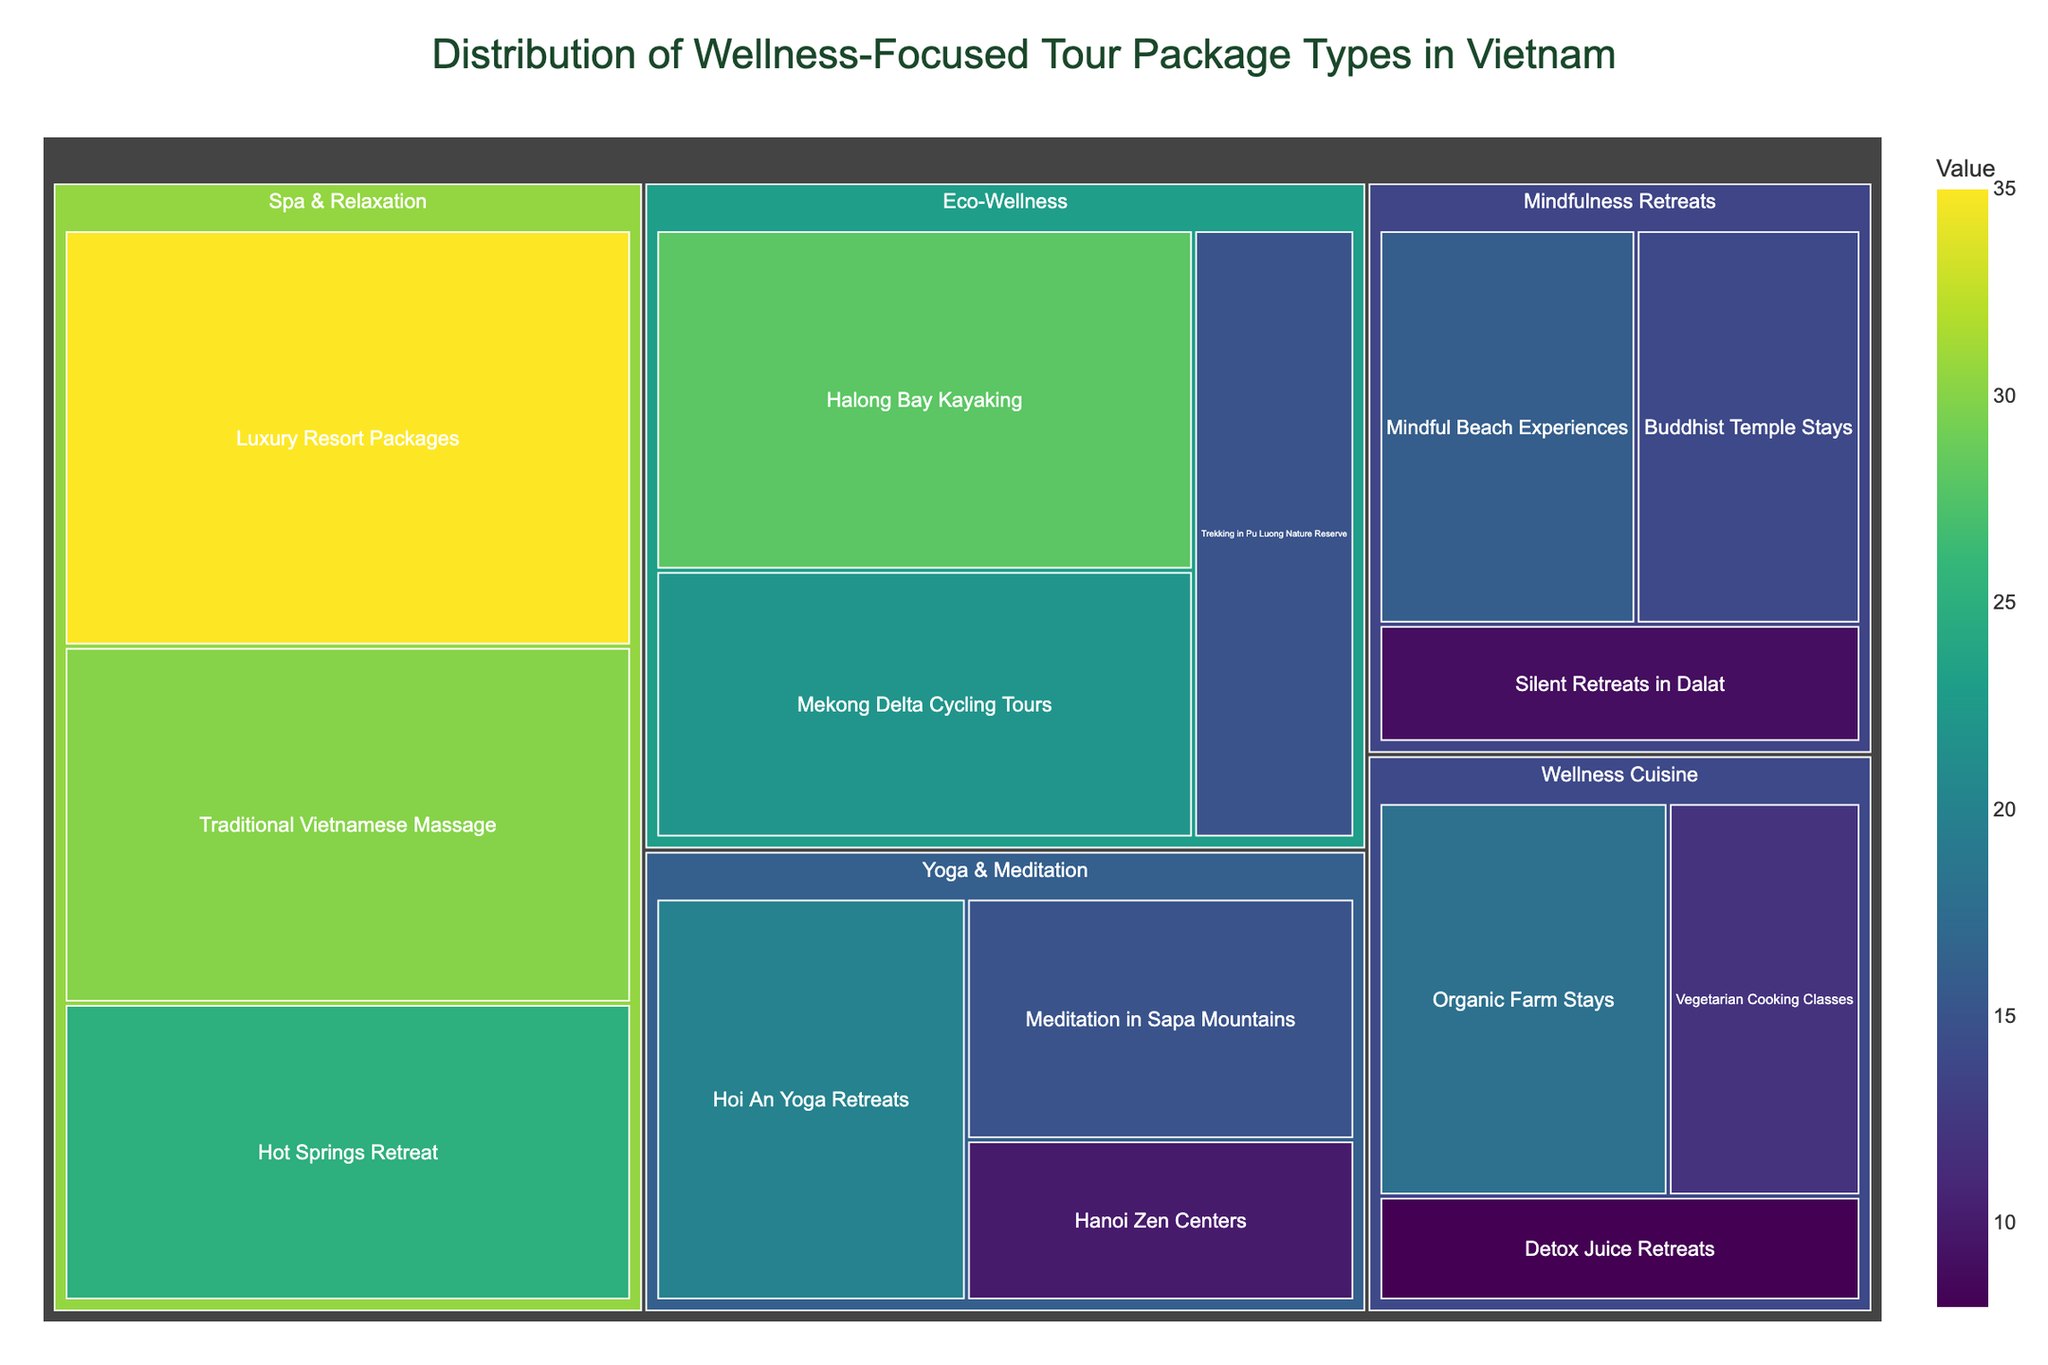what is the title of the figure? The title is displayed prominently at the top of the figure. It provides an overview of what the figure is about.
Answer: Distribution of Wellness-Focused Tour Package Types in Vietnam Which category has the highest value in the treemap? By looking at the sizes and colors of the rectangles, we see that "Spa & Relaxation" has the largest area and the darkest color, indicating it has the highest aggregated value.
Answer: Spa & Relaxation What is the smallest subcategory in the Spa & Relaxation category? Within the Spa & Relaxation category, we identify the smallest rectangle. "Hot Springs Retreat" appears smallest as it is lighter in color and has the smallest area.
Answer: Hot Springs Retreat How many subcategories are there under "Yoga & Meditation"? By counting the distinct subcategories listed under the "Yoga & Meditation" category on the treemap, we find three entries: Hoi An Yoga Retreats, Meditation in Sapa Mountains, and Hanoi Zen Centers.
Answer: 3 What's the difference in value between "Luxury Resort Packages" and "Traditional Vietnamese Massage"? We subtract the value of Traditional Vietnamese Massage (30) from the value of Luxury Resort Packages (35). This calculation gives us the difference.
Answer: 5 Which subcategory within "Wellness Cuisine" has the highest value? In the Wellness Cuisine category, the largest and darkest-colored rectangle represents "Organic Farm Stays".
Answer: Organic Farm Stays What is the combined value of all subcategories in the "Eco-Wellness" category? Summing up the values for all subcategories in Eco-Wellness: Mekong Delta Cycling Tours (22), Halong Bay Kayaking (28), and Trekking in Pu Luong Nature Reserve (15), we get 22 + 28 + 15 = 65.
Answer: 65 Which subcategory in the "Mindfulness Retreats" category has the lowest value? In the Mindfulness Retreats category, we identify "Silent Retreats in Dalat" as the smallest and lightest rectangle.
Answer: Silent Retreats in Dalat Compare the total value of "Yoga & Meditation" with "Wellness Cuisine". Which is higher and by how much? We sum the values for Yoga & Meditation (20 + 15 + 10 = 45) and Wellness Cuisine (18 + 12 + 8 = 38). By subtracting 38 from 45, we see the difference is 7, making Yoga & Meditation higher by 7.
Answer: Yoga & Meditation; 7 What is the average value of subcategories within the "Mindfulness Retreats"? Adding the values of all subcategories in Mindfulness Retreats (14 + 16 + 9) gives us 39. Dividing this sum by the number of subcategories (3) provides the average: 39 / 3 = 13.
Answer: 13 